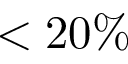<formula> <loc_0><loc_0><loc_500><loc_500>< 2 0 \%</formula> 